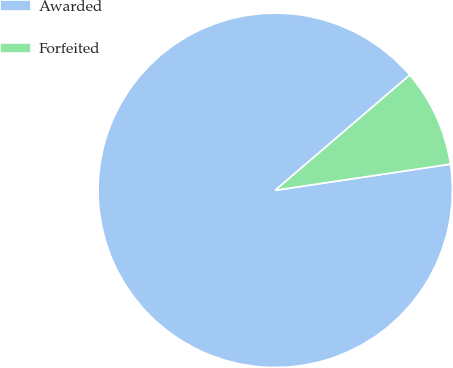Convert chart to OTSL. <chart><loc_0><loc_0><loc_500><loc_500><pie_chart><fcel>Awarded<fcel>Forfeited<nl><fcel>91.09%<fcel>8.91%<nl></chart> 